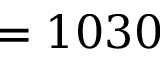<formula> <loc_0><loc_0><loc_500><loc_500>= 1 0 3 0</formula> 